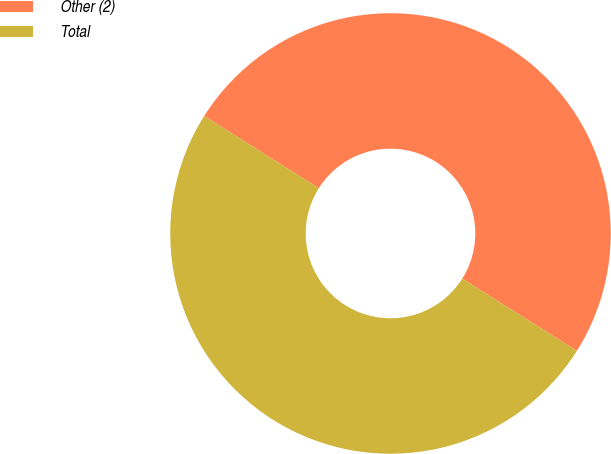<chart> <loc_0><loc_0><loc_500><loc_500><pie_chart><fcel>Other (2)<fcel>Total<nl><fcel>49.99%<fcel>50.01%<nl></chart> 